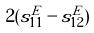<formula> <loc_0><loc_0><loc_500><loc_500>2 ( s _ { 1 1 } ^ { E } - s _ { 1 2 } ^ { E } )</formula> 